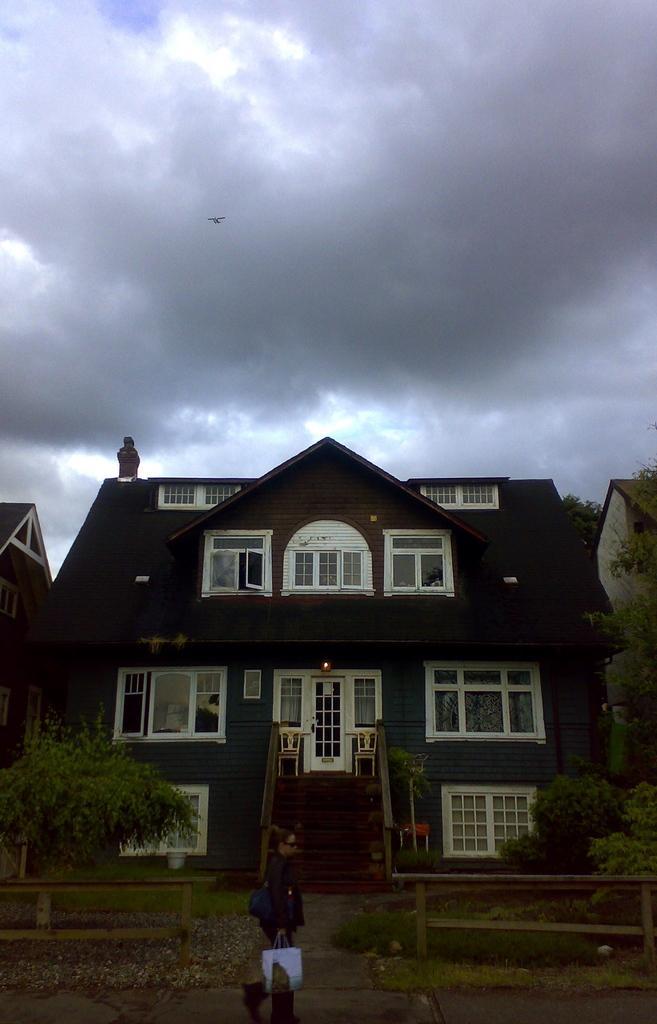Please provide a concise description of this image. The woman in front of the picture wearing black jacket is holding a white plastic bag in her hand. She is walking on the road. Beside her, we see an iron railing and trees. In the background, we see a building which is brown in color. At the top of the picture, we see the bird flying in the sky. We even see the clouds. 